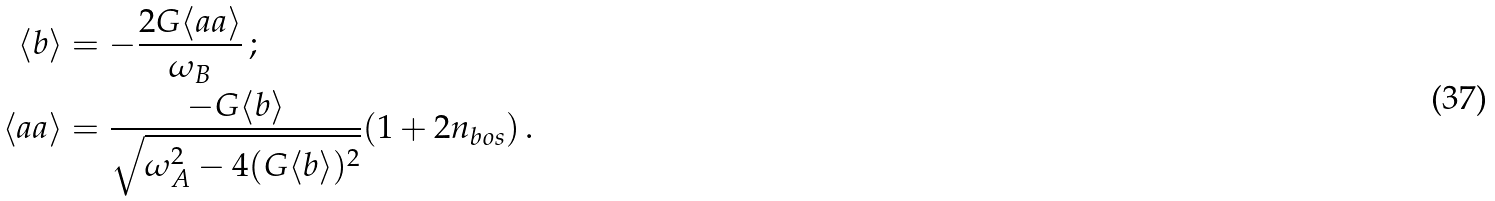<formula> <loc_0><loc_0><loc_500><loc_500>\langle b \rangle & = - \frac { 2 G \langle a a \rangle } { \omega _ { B } } \, ; \\ \langle a a \rangle & = \frac { - G \langle b \rangle } { \sqrt { \omega _ { A } ^ { 2 } - 4 ( G \langle b \rangle ) ^ { 2 } } } ( 1 + 2 n _ { b o s } ) \, .</formula> 